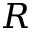<formula> <loc_0><loc_0><loc_500><loc_500>R</formula> 